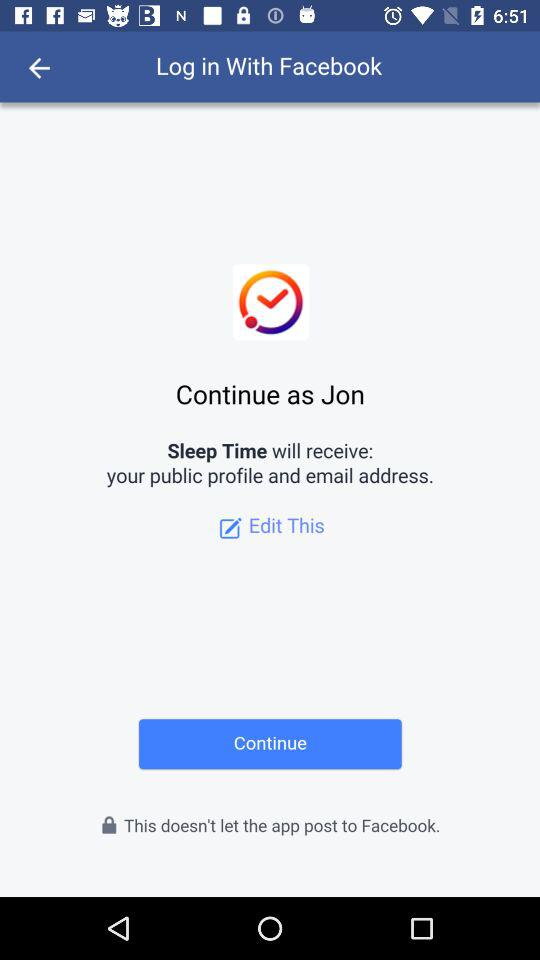What application can be used to log in? The application is "Facebook". 